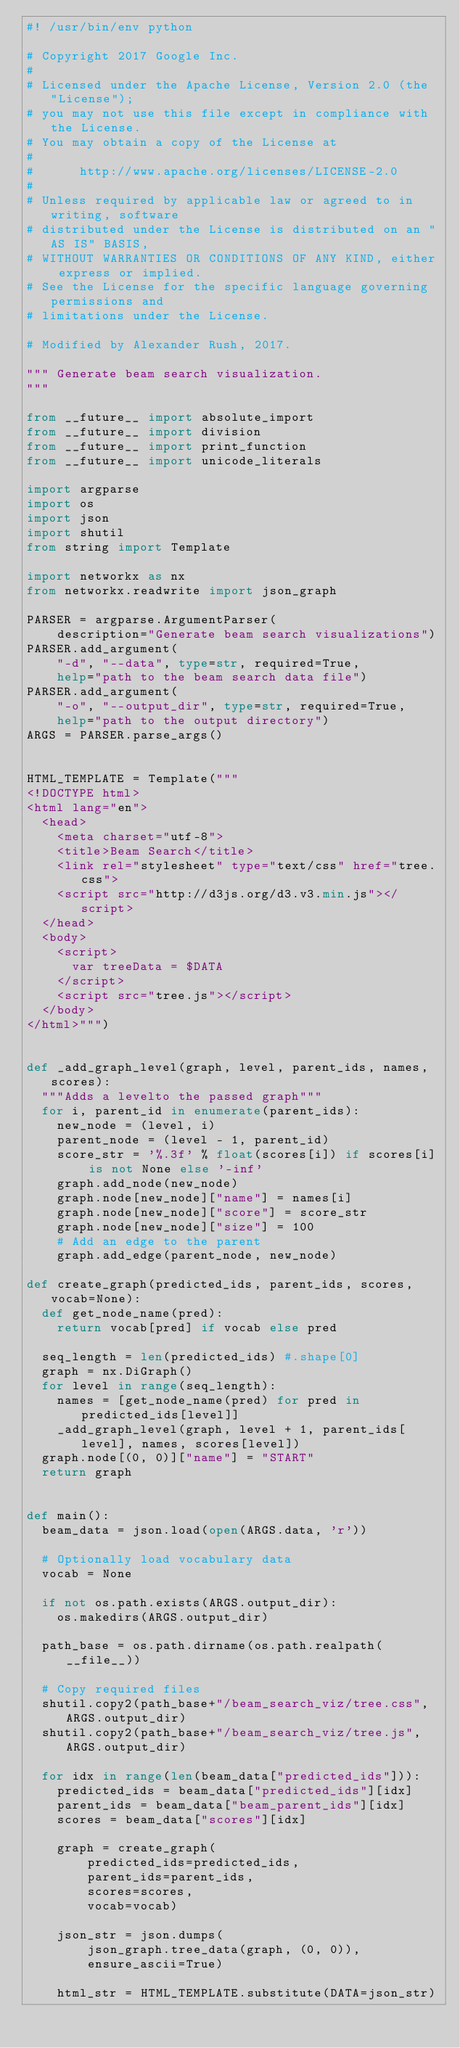Convert code to text. <code><loc_0><loc_0><loc_500><loc_500><_Python_>#! /usr/bin/env python

# Copyright 2017 Google Inc.
#
# Licensed under the Apache License, Version 2.0 (the "License");
# you may not use this file except in compliance with the License.
# You may obtain a copy of the License at
#
#      http://www.apache.org/licenses/LICENSE-2.0
#
# Unless required by applicable law or agreed to in writing, software
# distributed under the License is distributed on an "AS IS" BASIS,
# WITHOUT WARRANTIES OR CONDITIONS OF ANY KIND, either express or implied.
# See the License for the specific language governing permissions and
# limitations under the License.

# Modified by Alexander Rush, 2017.

""" Generate beam search visualization.
"""

from __future__ import absolute_import
from __future__ import division
from __future__ import print_function
from __future__ import unicode_literals

import argparse
import os
import json
import shutil
from string import Template

import networkx as nx
from networkx.readwrite import json_graph

PARSER = argparse.ArgumentParser(
    description="Generate beam search visualizations")
PARSER.add_argument(
    "-d", "--data", type=str, required=True,
    help="path to the beam search data file")
PARSER.add_argument(
    "-o", "--output_dir", type=str, required=True,
    help="path to the output directory")
ARGS = PARSER.parse_args()


HTML_TEMPLATE = Template("""
<!DOCTYPE html>
<html lang="en">
  <head>
    <meta charset="utf-8">
    <title>Beam Search</title>
    <link rel="stylesheet" type="text/css" href="tree.css">
    <script src="http://d3js.org/d3.v3.min.js"></script>
  </head>
  <body>
    <script>
      var treeData = $DATA
    </script>
    <script src="tree.js"></script>
  </body>
</html>""")


def _add_graph_level(graph, level, parent_ids, names, scores):
  """Adds a levelto the passed graph"""
  for i, parent_id in enumerate(parent_ids):
    new_node = (level, i)
    parent_node = (level - 1, parent_id)
    score_str = '%.3f' % float(scores[i]) if scores[i] is not None else '-inf'
    graph.add_node(new_node)
    graph.node[new_node]["name"] = names[i]
    graph.node[new_node]["score"] = score_str
    graph.node[new_node]["size"] = 100
    # Add an edge to the parent
    graph.add_edge(parent_node, new_node)

def create_graph(predicted_ids, parent_ids, scores, vocab=None):
  def get_node_name(pred):
    return vocab[pred] if vocab else pred

  seq_length = len(predicted_ids) #.shape[0]
  graph = nx.DiGraph()
  for level in range(seq_length):
    names = [get_node_name(pred) for pred in predicted_ids[level]]
    _add_graph_level(graph, level + 1, parent_ids[level], names, scores[level])
  graph.node[(0, 0)]["name"] = "START"
  return graph


def main():
  beam_data = json.load(open(ARGS.data, 'r'))

  # Optionally load vocabulary data
  vocab = None

  if not os.path.exists(ARGS.output_dir):
    os.makedirs(ARGS.output_dir)

  path_base = os.path.dirname(os.path.realpath(__file__))

  # Copy required files
  shutil.copy2(path_base+"/beam_search_viz/tree.css", ARGS.output_dir)
  shutil.copy2(path_base+"/beam_search_viz/tree.js", ARGS.output_dir)

  for idx in range(len(beam_data["predicted_ids"])):
    predicted_ids = beam_data["predicted_ids"][idx]
    parent_ids = beam_data["beam_parent_ids"][idx]
    scores = beam_data["scores"][idx]

    graph = create_graph(
        predicted_ids=predicted_ids,
        parent_ids=parent_ids,
        scores=scores,
        vocab=vocab)

    json_str = json.dumps(
        json_graph.tree_data(graph, (0, 0)),
        ensure_ascii=True)

    html_str = HTML_TEMPLATE.substitute(DATA=json_str)</code> 